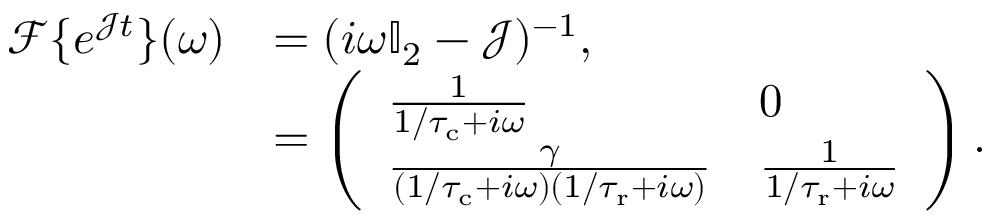Convert formula to latex. <formula><loc_0><loc_0><loc_500><loc_500>\begin{array} { r l } { \mathcal { F } \{ e ^ { \mathcal { J } t } \} ( \omega ) } & { = ( i \omega \mathbb { I } _ { 2 } - \mathcal { J } ) ^ { - 1 } , } \\ & { = \left ( \begin{array} { l l } { \frac { 1 } { 1 / { \tau _ { c } } + i \omega } } & { 0 } \\ { \frac { \gamma } { ( 1 / { \tau _ { c } } + i \omega ) ( 1 / { \tau _ { r } } + i \omega ) } } & { \frac { 1 } { 1 / { \tau _ { r } } + i \omega } } \end{array} \right ) . } \end{array}</formula> 